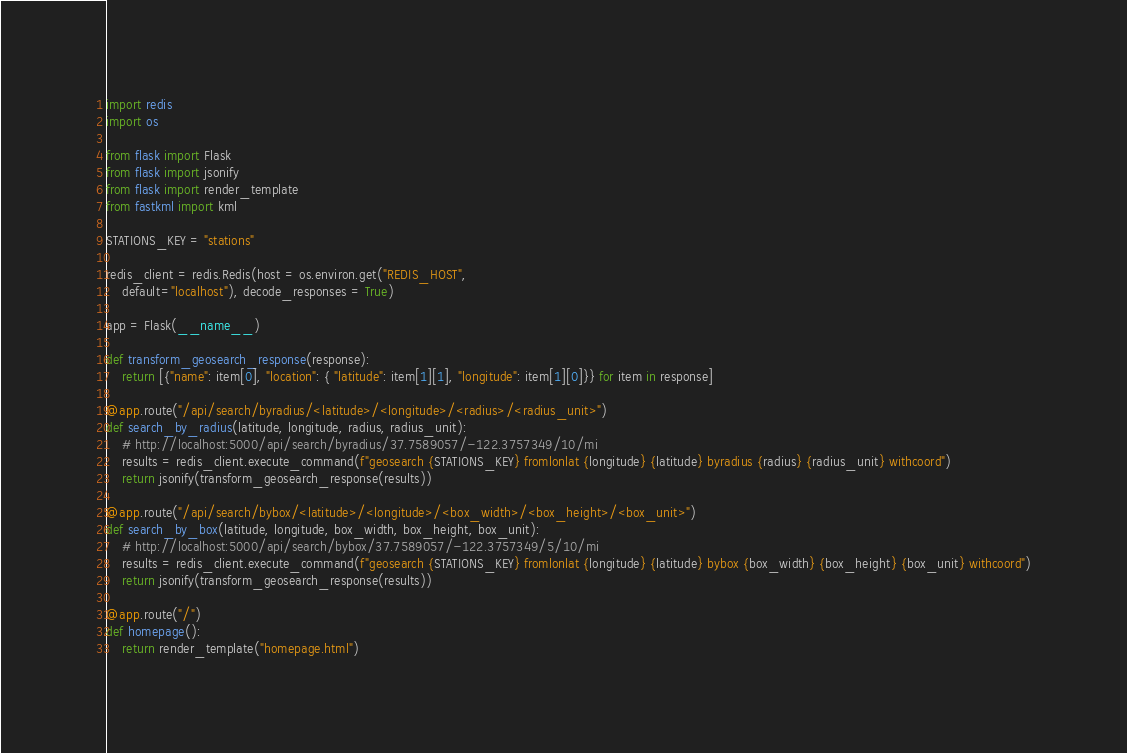<code> <loc_0><loc_0><loc_500><loc_500><_Python_>import redis
import os

from flask import Flask
from flask import jsonify
from flask import render_template
from fastkml import kml

STATIONS_KEY = "stations"

redis_client = redis.Redis(host = os.environ.get("REDIS_HOST",
    default="localhost"), decode_responses = True)

app = Flask(__name__)

def transform_geosearch_response(response):
    return [{"name": item[0], "location": { "latitude": item[1][1], "longitude": item[1][0]}} for item in response]

@app.route("/api/search/byradius/<latitude>/<longitude>/<radius>/<radius_unit>")
def search_by_radius(latitude, longitude, radius, radius_unit):
    # http://localhost:5000/api/search/byradius/37.7589057/-122.3757349/10/mi
    results = redis_client.execute_command(f"geosearch {STATIONS_KEY} fromlonlat {longitude} {latitude} byradius {radius} {radius_unit} withcoord")
    return jsonify(transform_geosearch_response(results))

@app.route("/api/search/bybox/<latitude>/<longitude>/<box_width>/<box_height>/<box_unit>")
def search_by_box(latitude, longitude, box_width, box_height, box_unit):
    # http://localhost:5000/api/search/bybox/37.7589057/-122.3757349/5/10/mi
    results = redis_client.execute_command(f"geosearch {STATIONS_KEY} fromlonlat {longitude} {latitude} bybox {box_width} {box_height} {box_unit} withcoord")
    return jsonify(transform_geosearch_response(results))

@app.route("/")
def homepage():
    return render_template("homepage.html")
</code> 